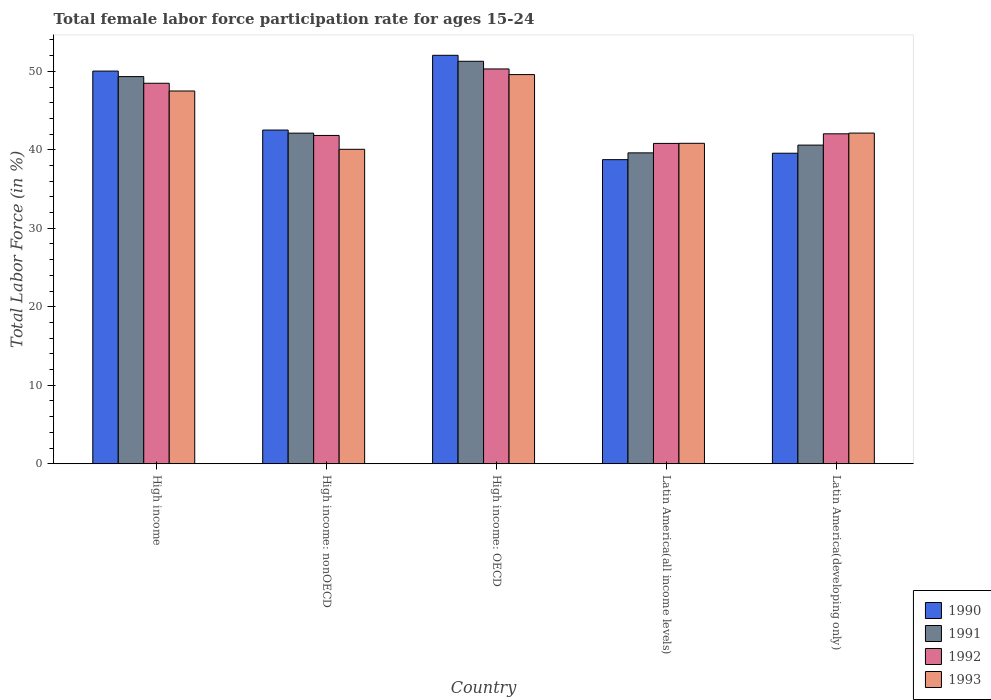Are the number of bars per tick equal to the number of legend labels?
Offer a terse response. Yes. What is the female labor force participation rate in 1993 in High income: nonOECD?
Offer a very short reply. 40.07. Across all countries, what is the maximum female labor force participation rate in 1992?
Your answer should be very brief. 50.3. Across all countries, what is the minimum female labor force participation rate in 1992?
Provide a short and direct response. 40.82. In which country was the female labor force participation rate in 1991 maximum?
Make the answer very short. High income: OECD. In which country was the female labor force participation rate in 1991 minimum?
Your answer should be compact. Latin America(all income levels). What is the total female labor force participation rate in 1990 in the graph?
Your answer should be compact. 222.91. What is the difference between the female labor force participation rate in 1990 in High income: nonOECD and that in Latin America(all income levels)?
Provide a succinct answer. 3.77. What is the difference between the female labor force participation rate in 1993 in High income: nonOECD and the female labor force participation rate in 1992 in Latin America(developing only)?
Provide a succinct answer. -1.97. What is the average female labor force participation rate in 1991 per country?
Provide a succinct answer. 44.59. What is the difference between the female labor force participation rate of/in 1993 and female labor force participation rate of/in 1992 in High income?
Provide a succinct answer. -0.99. In how many countries, is the female labor force participation rate in 1993 greater than 8 %?
Provide a succinct answer. 5. What is the ratio of the female labor force participation rate in 1993 in High income to that in High income: OECD?
Your response must be concise. 0.96. Is the difference between the female labor force participation rate in 1993 in Latin America(all income levels) and Latin America(developing only) greater than the difference between the female labor force participation rate in 1992 in Latin America(all income levels) and Latin America(developing only)?
Provide a short and direct response. No. What is the difference between the highest and the second highest female labor force participation rate in 1992?
Your response must be concise. -1.82. What is the difference between the highest and the lowest female labor force participation rate in 1992?
Your response must be concise. 9.49. Is it the case that in every country, the sum of the female labor force participation rate in 1991 and female labor force participation rate in 1993 is greater than the sum of female labor force participation rate in 1992 and female labor force participation rate in 1990?
Your response must be concise. No. What does the 2nd bar from the right in High income: OECD represents?
Your answer should be compact. 1992. How many countries are there in the graph?
Your answer should be very brief. 5. Does the graph contain any zero values?
Your response must be concise. No. How are the legend labels stacked?
Provide a short and direct response. Vertical. What is the title of the graph?
Make the answer very short. Total female labor force participation rate for ages 15-24. What is the Total Labor Force (in %) in 1990 in High income?
Offer a very short reply. 50.03. What is the Total Labor Force (in %) in 1991 in High income?
Your answer should be very brief. 49.33. What is the Total Labor Force (in %) in 1992 in High income?
Offer a very short reply. 48.48. What is the Total Labor Force (in %) of 1993 in High income?
Offer a very short reply. 47.5. What is the Total Labor Force (in %) in 1990 in High income: nonOECD?
Provide a short and direct response. 42.52. What is the Total Labor Force (in %) in 1991 in High income: nonOECD?
Your response must be concise. 42.12. What is the Total Labor Force (in %) of 1992 in High income: nonOECD?
Provide a succinct answer. 41.83. What is the Total Labor Force (in %) of 1993 in High income: nonOECD?
Offer a terse response. 40.07. What is the Total Labor Force (in %) of 1990 in High income: OECD?
Offer a terse response. 52.04. What is the Total Labor Force (in %) in 1991 in High income: OECD?
Your answer should be compact. 51.28. What is the Total Labor Force (in %) in 1992 in High income: OECD?
Provide a short and direct response. 50.3. What is the Total Labor Force (in %) of 1993 in High income: OECD?
Your answer should be compact. 49.59. What is the Total Labor Force (in %) of 1990 in Latin America(all income levels)?
Ensure brevity in your answer.  38.75. What is the Total Labor Force (in %) of 1991 in Latin America(all income levels)?
Offer a terse response. 39.61. What is the Total Labor Force (in %) in 1992 in Latin America(all income levels)?
Your response must be concise. 40.82. What is the Total Labor Force (in %) of 1993 in Latin America(all income levels)?
Ensure brevity in your answer.  40.83. What is the Total Labor Force (in %) of 1990 in Latin America(developing only)?
Make the answer very short. 39.57. What is the Total Labor Force (in %) in 1991 in Latin America(developing only)?
Ensure brevity in your answer.  40.6. What is the Total Labor Force (in %) of 1992 in Latin America(developing only)?
Give a very brief answer. 42.04. What is the Total Labor Force (in %) of 1993 in Latin America(developing only)?
Offer a terse response. 42.13. Across all countries, what is the maximum Total Labor Force (in %) in 1990?
Offer a very short reply. 52.04. Across all countries, what is the maximum Total Labor Force (in %) in 1991?
Provide a succinct answer. 51.28. Across all countries, what is the maximum Total Labor Force (in %) in 1992?
Provide a succinct answer. 50.3. Across all countries, what is the maximum Total Labor Force (in %) of 1993?
Keep it short and to the point. 49.59. Across all countries, what is the minimum Total Labor Force (in %) in 1990?
Your answer should be compact. 38.75. Across all countries, what is the minimum Total Labor Force (in %) of 1991?
Your response must be concise. 39.61. Across all countries, what is the minimum Total Labor Force (in %) of 1992?
Your answer should be very brief. 40.82. Across all countries, what is the minimum Total Labor Force (in %) of 1993?
Make the answer very short. 40.07. What is the total Total Labor Force (in %) in 1990 in the graph?
Offer a terse response. 222.91. What is the total Total Labor Force (in %) in 1991 in the graph?
Provide a short and direct response. 222.95. What is the total Total Labor Force (in %) in 1992 in the graph?
Ensure brevity in your answer.  223.47. What is the total Total Labor Force (in %) of 1993 in the graph?
Your answer should be very brief. 220.11. What is the difference between the Total Labor Force (in %) of 1990 in High income and that in High income: nonOECD?
Offer a very short reply. 7.52. What is the difference between the Total Labor Force (in %) in 1991 in High income and that in High income: nonOECD?
Offer a terse response. 7.2. What is the difference between the Total Labor Force (in %) in 1992 in High income and that in High income: nonOECD?
Give a very brief answer. 6.65. What is the difference between the Total Labor Force (in %) in 1993 in High income and that in High income: nonOECD?
Provide a succinct answer. 7.43. What is the difference between the Total Labor Force (in %) of 1990 in High income and that in High income: OECD?
Offer a very short reply. -2.01. What is the difference between the Total Labor Force (in %) of 1991 in High income and that in High income: OECD?
Give a very brief answer. -1.95. What is the difference between the Total Labor Force (in %) of 1992 in High income and that in High income: OECD?
Ensure brevity in your answer.  -1.82. What is the difference between the Total Labor Force (in %) of 1993 in High income and that in High income: OECD?
Offer a terse response. -2.09. What is the difference between the Total Labor Force (in %) in 1990 in High income and that in Latin America(all income levels)?
Your response must be concise. 11.29. What is the difference between the Total Labor Force (in %) in 1991 in High income and that in Latin America(all income levels)?
Offer a terse response. 9.72. What is the difference between the Total Labor Force (in %) of 1992 in High income and that in Latin America(all income levels)?
Ensure brevity in your answer.  7.67. What is the difference between the Total Labor Force (in %) in 1993 in High income and that in Latin America(all income levels)?
Ensure brevity in your answer.  6.66. What is the difference between the Total Labor Force (in %) of 1990 in High income and that in Latin America(developing only)?
Your response must be concise. 10.47. What is the difference between the Total Labor Force (in %) in 1991 in High income and that in Latin America(developing only)?
Keep it short and to the point. 8.73. What is the difference between the Total Labor Force (in %) in 1992 in High income and that in Latin America(developing only)?
Keep it short and to the point. 6.44. What is the difference between the Total Labor Force (in %) of 1993 in High income and that in Latin America(developing only)?
Give a very brief answer. 5.36. What is the difference between the Total Labor Force (in %) in 1990 in High income: nonOECD and that in High income: OECD?
Provide a succinct answer. -9.53. What is the difference between the Total Labor Force (in %) of 1991 in High income: nonOECD and that in High income: OECD?
Provide a short and direct response. -9.16. What is the difference between the Total Labor Force (in %) of 1992 in High income: nonOECD and that in High income: OECD?
Ensure brevity in your answer.  -8.47. What is the difference between the Total Labor Force (in %) in 1993 in High income: nonOECD and that in High income: OECD?
Your response must be concise. -9.52. What is the difference between the Total Labor Force (in %) in 1990 in High income: nonOECD and that in Latin America(all income levels)?
Keep it short and to the point. 3.77. What is the difference between the Total Labor Force (in %) in 1991 in High income: nonOECD and that in Latin America(all income levels)?
Offer a terse response. 2.51. What is the difference between the Total Labor Force (in %) of 1992 in High income: nonOECD and that in Latin America(all income levels)?
Offer a terse response. 1.02. What is the difference between the Total Labor Force (in %) of 1993 in High income: nonOECD and that in Latin America(all income levels)?
Offer a very short reply. -0.76. What is the difference between the Total Labor Force (in %) in 1990 in High income: nonOECD and that in Latin America(developing only)?
Keep it short and to the point. 2.95. What is the difference between the Total Labor Force (in %) of 1991 in High income: nonOECD and that in Latin America(developing only)?
Provide a succinct answer. 1.52. What is the difference between the Total Labor Force (in %) in 1992 in High income: nonOECD and that in Latin America(developing only)?
Give a very brief answer. -0.21. What is the difference between the Total Labor Force (in %) of 1993 in High income: nonOECD and that in Latin America(developing only)?
Offer a terse response. -2.07. What is the difference between the Total Labor Force (in %) of 1990 in High income: OECD and that in Latin America(all income levels)?
Your response must be concise. 13.3. What is the difference between the Total Labor Force (in %) in 1991 in High income: OECD and that in Latin America(all income levels)?
Offer a very short reply. 11.67. What is the difference between the Total Labor Force (in %) of 1992 in High income: OECD and that in Latin America(all income levels)?
Your answer should be very brief. 9.49. What is the difference between the Total Labor Force (in %) of 1993 in High income: OECD and that in Latin America(all income levels)?
Ensure brevity in your answer.  8.76. What is the difference between the Total Labor Force (in %) in 1990 in High income: OECD and that in Latin America(developing only)?
Ensure brevity in your answer.  12.48. What is the difference between the Total Labor Force (in %) of 1991 in High income: OECD and that in Latin America(developing only)?
Your response must be concise. 10.68. What is the difference between the Total Labor Force (in %) in 1992 in High income: OECD and that in Latin America(developing only)?
Provide a short and direct response. 8.26. What is the difference between the Total Labor Force (in %) in 1993 in High income: OECD and that in Latin America(developing only)?
Offer a very short reply. 7.45. What is the difference between the Total Labor Force (in %) of 1990 in Latin America(all income levels) and that in Latin America(developing only)?
Provide a succinct answer. -0.82. What is the difference between the Total Labor Force (in %) in 1991 in Latin America(all income levels) and that in Latin America(developing only)?
Your response must be concise. -0.99. What is the difference between the Total Labor Force (in %) in 1992 in Latin America(all income levels) and that in Latin America(developing only)?
Offer a terse response. -1.23. What is the difference between the Total Labor Force (in %) in 1993 in Latin America(all income levels) and that in Latin America(developing only)?
Your response must be concise. -1.3. What is the difference between the Total Labor Force (in %) of 1990 in High income and the Total Labor Force (in %) of 1991 in High income: nonOECD?
Your answer should be compact. 7.91. What is the difference between the Total Labor Force (in %) of 1990 in High income and the Total Labor Force (in %) of 1992 in High income: nonOECD?
Ensure brevity in your answer.  8.2. What is the difference between the Total Labor Force (in %) in 1990 in High income and the Total Labor Force (in %) in 1993 in High income: nonOECD?
Give a very brief answer. 9.97. What is the difference between the Total Labor Force (in %) in 1991 in High income and the Total Labor Force (in %) in 1992 in High income: nonOECD?
Keep it short and to the point. 7.5. What is the difference between the Total Labor Force (in %) in 1991 in High income and the Total Labor Force (in %) in 1993 in High income: nonOECD?
Keep it short and to the point. 9.26. What is the difference between the Total Labor Force (in %) in 1992 in High income and the Total Labor Force (in %) in 1993 in High income: nonOECD?
Offer a terse response. 8.42. What is the difference between the Total Labor Force (in %) of 1990 in High income and the Total Labor Force (in %) of 1991 in High income: OECD?
Your answer should be very brief. -1.25. What is the difference between the Total Labor Force (in %) of 1990 in High income and the Total Labor Force (in %) of 1992 in High income: OECD?
Give a very brief answer. -0.27. What is the difference between the Total Labor Force (in %) in 1990 in High income and the Total Labor Force (in %) in 1993 in High income: OECD?
Offer a very short reply. 0.45. What is the difference between the Total Labor Force (in %) in 1991 in High income and the Total Labor Force (in %) in 1992 in High income: OECD?
Your response must be concise. -0.98. What is the difference between the Total Labor Force (in %) in 1991 in High income and the Total Labor Force (in %) in 1993 in High income: OECD?
Provide a succinct answer. -0.26. What is the difference between the Total Labor Force (in %) of 1992 in High income and the Total Labor Force (in %) of 1993 in High income: OECD?
Your answer should be compact. -1.1. What is the difference between the Total Labor Force (in %) of 1990 in High income and the Total Labor Force (in %) of 1991 in Latin America(all income levels)?
Keep it short and to the point. 10.42. What is the difference between the Total Labor Force (in %) of 1990 in High income and the Total Labor Force (in %) of 1992 in Latin America(all income levels)?
Offer a terse response. 9.22. What is the difference between the Total Labor Force (in %) in 1990 in High income and the Total Labor Force (in %) in 1993 in Latin America(all income levels)?
Offer a terse response. 9.2. What is the difference between the Total Labor Force (in %) in 1991 in High income and the Total Labor Force (in %) in 1992 in Latin America(all income levels)?
Offer a terse response. 8.51. What is the difference between the Total Labor Force (in %) of 1991 in High income and the Total Labor Force (in %) of 1993 in Latin America(all income levels)?
Your response must be concise. 8.5. What is the difference between the Total Labor Force (in %) in 1992 in High income and the Total Labor Force (in %) in 1993 in Latin America(all income levels)?
Your response must be concise. 7.65. What is the difference between the Total Labor Force (in %) in 1990 in High income and the Total Labor Force (in %) in 1991 in Latin America(developing only)?
Make the answer very short. 9.43. What is the difference between the Total Labor Force (in %) of 1990 in High income and the Total Labor Force (in %) of 1992 in Latin America(developing only)?
Your answer should be compact. 7.99. What is the difference between the Total Labor Force (in %) in 1990 in High income and the Total Labor Force (in %) in 1993 in Latin America(developing only)?
Make the answer very short. 7.9. What is the difference between the Total Labor Force (in %) of 1991 in High income and the Total Labor Force (in %) of 1992 in Latin America(developing only)?
Offer a very short reply. 7.29. What is the difference between the Total Labor Force (in %) of 1991 in High income and the Total Labor Force (in %) of 1993 in Latin America(developing only)?
Offer a terse response. 7.2. What is the difference between the Total Labor Force (in %) in 1992 in High income and the Total Labor Force (in %) in 1993 in Latin America(developing only)?
Your answer should be very brief. 6.35. What is the difference between the Total Labor Force (in %) of 1990 in High income: nonOECD and the Total Labor Force (in %) of 1991 in High income: OECD?
Provide a short and direct response. -8.76. What is the difference between the Total Labor Force (in %) in 1990 in High income: nonOECD and the Total Labor Force (in %) in 1992 in High income: OECD?
Your answer should be very brief. -7.79. What is the difference between the Total Labor Force (in %) in 1990 in High income: nonOECD and the Total Labor Force (in %) in 1993 in High income: OECD?
Ensure brevity in your answer.  -7.07. What is the difference between the Total Labor Force (in %) of 1991 in High income: nonOECD and the Total Labor Force (in %) of 1992 in High income: OECD?
Offer a very short reply. -8.18. What is the difference between the Total Labor Force (in %) in 1991 in High income: nonOECD and the Total Labor Force (in %) in 1993 in High income: OECD?
Ensure brevity in your answer.  -7.46. What is the difference between the Total Labor Force (in %) in 1992 in High income: nonOECD and the Total Labor Force (in %) in 1993 in High income: OECD?
Your response must be concise. -7.75. What is the difference between the Total Labor Force (in %) of 1990 in High income: nonOECD and the Total Labor Force (in %) of 1991 in Latin America(all income levels)?
Give a very brief answer. 2.91. What is the difference between the Total Labor Force (in %) of 1990 in High income: nonOECD and the Total Labor Force (in %) of 1992 in Latin America(all income levels)?
Ensure brevity in your answer.  1.7. What is the difference between the Total Labor Force (in %) in 1990 in High income: nonOECD and the Total Labor Force (in %) in 1993 in Latin America(all income levels)?
Keep it short and to the point. 1.69. What is the difference between the Total Labor Force (in %) in 1991 in High income: nonOECD and the Total Labor Force (in %) in 1992 in Latin America(all income levels)?
Make the answer very short. 1.31. What is the difference between the Total Labor Force (in %) in 1991 in High income: nonOECD and the Total Labor Force (in %) in 1993 in Latin America(all income levels)?
Offer a very short reply. 1.29. What is the difference between the Total Labor Force (in %) in 1990 in High income: nonOECD and the Total Labor Force (in %) in 1991 in Latin America(developing only)?
Your answer should be very brief. 1.92. What is the difference between the Total Labor Force (in %) of 1990 in High income: nonOECD and the Total Labor Force (in %) of 1992 in Latin America(developing only)?
Make the answer very short. 0.48. What is the difference between the Total Labor Force (in %) of 1990 in High income: nonOECD and the Total Labor Force (in %) of 1993 in Latin America(developing only)?
Give a very brief answer. 0.39. What is the difference between the Total Labor Force (in %) of 1991 in High income: nonOECD and the Total Labor Force (in %) of 1992 in Latin America(developing only)?
Give a very brief answer. 0.08. What is the difference between the Total Labor Force (in %) of 1991 in High income: nonOECD and the Total Labor Force (in %) of 1993 in Latin America(developing only)?
Your answer should be compact. -0.01. What is the difference between the Total Labor Force (in %) in 1992 in High income: nonOECD and the Total Labor Force (in %) in 1993 in Latin America(developing only)?
Your answer should be compact. -0.3. What is the difference between the Total Labor Force (in %) of 1990 in High income: OECD and the Total Labor Force (in %) of 1991 in Latin America(all income levels)?
Provide a short and direct response. 12.43. What is the difference between the Total Labor Force (in %) in 1990 in High income: OECD and the Total Labor Force (in %) in 1992 in Latin America(all income levels)?
Give a very brief answer. 11.23. What is the difference between the Total Labor Force (in %) of 1990 in High income: OECD and the Total Labor Force (in %) of 1993 in Latin America(all income levels)?
Offer a very short reply. 11.21. What is the difference between the Total Labor Force (in %) in 1991 in High income: OECD and the Total Labor Force (in %) in 1992 in Latin America(all income levels)?
Provide a short and direct response. 10.47. What is the difference between the Total Labor Force (in %) in 1991 in High income: OECD and the Total Labor Force (in %) in 1993 in Latin America(all income levels)?
Give a very brief answer. 10.45. What is the difference between the Total Labor Force (in %) of 1992 in High income: OECD and the Total Labor Force (in %) of 1993 in Latin America(all income levels)?
Your answer should be compact. 9.47. What is the difference between the Total Labor Force (in %) of 1990 in High income: OECD and the Total Labor Force (in %) of 1991 in Latin America(developing only)?
Your answer should be very brief. 11.44. What is the difference between the Total Labor Force (in %) of 1990 in High income: OECD and the Total Labor Force (in %) of 1992 in Latin America(developing only)?
Keep it short and to the point. 10. What is the difference between the Total Labor Force (in %) of 1990 in High income: OECD and the Total Labor Force (in %) of 1993 in Latin America(developing only)?
Offer a very short reply. 9.91. What is the difference between the Total Labor Force (in %) in 1991 in High income: OECD and the Total Labor Force (in %) in 1992 in Latin America(developing only)?
Your response must be concise. 9.24. What is the difference between the Total Labor Force (in %) in 1991 in High income: OECD and the Total Labor Force (in %) in 1993 in Latin America(developing only)?
Provide a short and direct response. 9.15. What is the difference between the Total Labor Force (in %) of 1992 in High income: OECD and the Total Labor Force (in %) of 1993 in Latin America(developing only)?
Give a very brief answer. 8.17. What is the difference between the Total Labor Force (in %) of 1990 in Latin America(all income levels) and the Total Labor Force (in %) of 1991 in Latin America(developing only)?
Offer a terse response. -1.85. What is the difference between the Total Labor Force (in %) in 1990 in Latin America(all income levels) and the Total Labor Force (in %) in 1992 in Latin America(developing only)?
Offer a terse response. -3.29. What is the difference between the Total Labor Force (in %) of 1990 in Latin America(all income levels) and the Total Labor Force (in %) of 1993 in Latin America(developing only)?
Give a very brief answer. -3.38. What is the difference between the Total Labor Force (in %) of 1991 in Latin America(all income levels) and the Total Labor Force (in %) of 1992 in Latin America(developing only)?
Your answer should be compact. -2.43. What is the difference between the Total Labor Force (in %) of 1991 in Latin America(all income levels) and the Total Labor Force (in %) of 1993 in Latin America(developing only)?
Give a very brief answer. -2.52. What is the difference between the Total Labor Force (in %) of 1992 in Latin America(all income levels) and the Total Labor Force (in %) of 1993 in Latin America(developing only)?
Your answer should be very brief. -1.32. What is the average Total Labor Force (in %) of 1990 per country?
Offer a terse response. 44.58. What is the average Total Labor Force (in %) of 1991 per country?
Offer a very short reply. 44.59. What is the average Total Labor Force (in %) of 1992 per country?
Provide a short and direct response. 44.69. What is the average Total Labor Force (in %) of 1993 per country?
Your answer should be very brief. 44.02. What is the difference between the Total Labor Force (in %) in 1990 and Total Labor Force (in %) in 1991 in High income?
Keep it short and to the point. 0.71. What is the difference between the Total Labor Force (in %) in 1990 and Total Labor Force (in %) in 1992 in High income?
Your answer should be very brief. 1.55. What is the difference between the Total Labor Force (in %) in 1990 and Total Labor Force (in %) in 1993 in High income?
Make the answer very short. 2.54. What is the difference between the Total Labor Force (in %) of 1991 and Total Labor Force (in %) of 1992 in High income?
Your response must be concise. 0.85. What is the difference between the Total Labor Force (in %) in 1991 and Total Labor Force (in %) in 1993 in High income?
Keep it short and to the point. 1.83. What is the difference between the Total Labor Force (in %) in 1992 and Total Labor Force (in %) in 1993 in High income?
Provide a short and direct response. 0.99. What is the difference between the Total Labor Force (in %) of 1990 and Total Labor Force (in %) of 1991 in High income: nonOECD?
Make the answer very short. 0.39. What is the difference between the Total Labor Force (in %) of 1990 and Total Labor Force (in %) of 1992 in High income: nonOECD?
Ensure brevity in your answer.  0.69. What is the difference between the Total Labor Force (in %) in 1990 and Total Labor Force (in %) in 1993 in High income: nonOECD?
Make the answer very short. 2.45. What is the difference between the Total Labor Force (in %) in 1991 and Total Labor Force (in %) in 1992 in High income: nonOECD?
Provide a succinct answer. 0.29. What is the difference between the Total Labor Force (in %) in 1991 and Total Labor Force (in %) in 1993 in High income: nonOECD?
Ensure brevity in your answer.  2.06. What is the difference between the Total Labor Force (in %) of 1992 and Total Labor Force (in %) of 1993 in High income: nonOECD?
Provide a succinct answer. 1.77. What is the difference between the Total Labor Force (in %) of 1990 and Total Labor Force (in %) of 1991 in High income: OECD?
Ensure brevity in your answer.  0.76. What is the difference between the Total Labor Force (in %) of 1990 and Total Labor Force (in %) of 1992 in High income: OECD?
Give a very brief answer. 1.74. What is the difference between the Total Labor Force (in %) of 1990 and Total Labor Force (in %) of 1993 in High income: OECD?
Provide a short and direct response. 2.46. What is the difference between the Total Labor Force (in %) in 1991 and Total Labor Force (in %) in 1992 in High income: OECD?
Offer a very short reply. 0.98. What is the difference between the Total Labor Force (in %) of 1991 and Total Labor Force (in %) of 1993 in High income: OECD?
Offer a terse response. 1.7. What is the difference between the Total Labor Force (in %) of 1992 and Total Labor Force (in %) of 1993 in High income: OECD?
Make the answer very short. 0.72. What is the difference between the Total Labor Force (in %) in 1990 and Total Labor Force (in %) in 1991 in Latin America(all income levels)?
Your answer should be compact. -0.86. What is the difference between the Total Labor Force (in %) of 1990 and Total Labor Force (in %) of 1992 in Latin America(all income levels)?
Ensure brevity in your answer.  -2.07. What is the difference between the Total Labor Force (in %) in 1990 and Total Labor Force (in %) in 1993 in Latin America(all income levels)?
Your answer should be very brief. -2.08. What is the difference between the Total Labor Force (in %) in 1991 and Total Labor Force (in %) in 1992 in Latin America(all income levels)?
Your answer should be very brief. -1.2. What is the difference between the Total Labor Force (in %) in 1991 and Total Labor Force (in %) in 1993 in Latin America(all income levels)?
Your answer should be very brief. -1.22. What is the difference between the Total Labor Force (in %) in 1992 and Total Labor Force (in %) in 1993 in Latin America(all income levels)?
Make the answer very short. -0.02. What is the difference between the Total Labor Force (in %) of 1990 and Total Labor Force (in %) of 1991 in Latin America(developing only)?
Your answer should be very brief. -1.04. What is the difference between the Total Labor Force (in %) of 1990 and Total Labor Force (in %) of 1992 in Latin America(developing only)?
Provide a succinct answer. -2.48. What is the difference between the Total Labor Force (in %) in 1990 and Total Labor Force (in %) in 1993 in Latin America(developing only)?
Offer a very short reply. -2.57. What is the difference between the Total Labor Force (in %) in 1991 and Total Labor Force (in %) in 1992 in Latin America(developing only)?
Provide a short and direct response. -1.44. What is the difference between the Total Labor Force (in %) in 1991 and Total Labor Force (in %) in 1993 in Latin America(developing only)?
Make the answer very short. -1.53. What is the difference between the Total Labor Force (in %) in 1992 and Total Labor Force (in %) in 1993 in Latin America(developing only)?
Ensure brevity in your answer.  -0.09. What is the ratio of the Total Labor Force (in %) in 1990 in High income to that in High income: nonOECD?
Offer a terse response. 1.18. What is the ratio of the Total Labor Force (in %) of 1991 in High income to that in High income: nonOECD?
Offer a terse response. 1.17. What is the ratio of the Total Labor Force (in %) in 1992 in High income to that in High income: nonOECD?
Ensure brevity in your answer.  1.16. What is the ratio of the Total Labor Force (in %) of 1993 in High income to that in High income: nonOECD?
Make the answer very short. 1.19. What is the ratio of the Total Labor Force (in %) of 1990 in High income to that in High income: OECD?
Provide a short and direct response. 0.96. What is the ratio of the Total Labor Force (in %) in 1991 in High income to that in High income: OECD?
Offer a very short reply. 0.96. What is the ratio of the Total Labor Force (in %) in 1992 in High income to that in High income: OECD?
Make the answer very short. 0.96. What is the ratio of the Total Labor Force (in %) in 1993 in High income to that in High income: OECD?
Keep it short and to the point. 0.96. What is the ratio of the Total Labor Force (in %) of 1990 in High income to that in Latin America(all income levels)?
Provide a succinct answer. 1.29. What is the ratio of the Total Labor Force (in %) of 1991 in High income to that in Latin America(all income levels)?
Your answer should be very brief. 1.25. What is the ratio of the Total Labor Force (in %) in 1992 in High income to that in Latin America(all income levels)?
Provide a short and direct response. 1.19. What is the ratio of the Total Labor Force (in %) of 1993 in High income to that in Latin America(all income levels)?
Provide a short and direct response. 1.16. What is the ratio of the Total Labor Force (in %) in 1990 in High income to that in Latin America(developing only)?
Offer a terse response. 1.26. What is the ratio of the Total Labor Force (in %) of 1991 in High income to that in Latin America(developing only)?
Your answer should be very brief. 1.22. What is the ratio of the Total Labor Force (in %) of 1992 in High income to that in Latin America(developing only)?
Provide a succinct answer. 1.15. What is the ratio of the Total Labor Force (in %) of 1993 in High income to that in Latin America(developing only)?
Provide a short and direct response. 1.13. What is the ratio of the Total Labor Force (in %) of 1990 in High income: nonOECD to that in High income: OECD?
Give a very brief answer. 0.82. What is the ratio of the Total Labor Force (in %) in 1991 in High income: nonOECD to that in High income: OECD?
Provide a succinct answer. 0.82. What is the ratio of the Total Labor Force (in %) of 1992 in High income: nonOECD to that in High income: OECD?
Provide a succinct answer. 0.83. What is the ratio of the Total Labor Force (in %) in 1993 in High income: nonOECD to that in High income: OECD?
Give a very brief answer. 0.81. What is the ratio of the Total Labor Force (in %) in 1990 in High income: nonOECD to that in Latin America(all income levels)?
Give a very brief answer. 1.1. What is the ratio of the Total Labor Force (in %) in 1991 in High income: nonOECD to that in Latin America(all income levels)?
Offer a very short reply. 1.06. What is the ratio of the Total Labor Force (in %) in 1992 in High income: nonOECD to that in Latin America(all income levels)?
Your response must be concise. 1.02. What is the ratio of the Total Labor Force (in %) in 1993 in High income: nonOECD to that in Latin America(all income levels)?
Offer a very short reply. 0.98. What is the ratio of the Total Labor Force (in %) of 1990 in High income: nonOECD to that in Latin America(developing only)?
Offer a very short reply. 1.07. What is the ratio of the Total Labor Force (in %) of 1991 in High income: nonOECD to that in Latin America(developing only)?
Offer a very short reply. 1.04. What is the ratio of the Total Labor Force (in %) of 1992 in High income: nonOECD to that in Latin America(developing only)?
Give a very brief answer. 0.99. What is the ratio of the Total Labor Force (in %) in 1993 in High income: nonOECD to that in Latin America(developing only)?
Provide a succinct answer. 0.95. What is the ratio of the Total Labor Force (in %) in 1990 in High income: OECD to that in Latin America(all income levels)?
Make the answer very short. 1.34. What is the ratio of the Total Labor Force (in %) in 1991 in High income: OECD to that in Latin America(all income levels)?
Make the answer very short. 1.29. What is the ratio of the Total Labor Force (in %) in 1992 in High income: OECD to that in Latin America(all income levels)?
Offer a terse response. 1.23. What is the ratio of the Total Labor Force (in %) in 1993 in High income: OECD to that in Latin America(all income levels)?
Make the answer very short. 1.21. What is the ratio of the Total Labor Force (in %) of 1990 in High income: OECD to that in Latin America(developing only)?
Offer a very short reply. 1.32. What is the ratio of the Total Labor Force (in %) in 1991 in High income: OECD to that in Latin America(developing only)?
Give a very brief answer. 1.26. What is the ratio of the Total Labor Force (in %) of 1992 in High income: OECD to that in Latin America(developing only)?
Provide a succinct answer. 1.2. What is the ratio of the Total Labor Force (in %) in 1993 in High income: OECD to that in Latin America(developing only)?
Offer a terse response. 1.18. What is the ratio of the Total Labor Force (in %) of 1990 in Latin America(all income levels) to that in Latin America(developing only)?
Provide a short and direct response. 0.98. What is the ratio of the Total Labor Force (in %) in 1991 in Latin America(all income levels) to that in Latin America(developing only)?
Ensure brevity in your answer.  0.98. What is the ratio of the Total Labor Force (in %) of 1992 in Latin America(all income levels) to that in Latin America(developing only)?
Offer a very short reply. 0.97. What is the ratio of the Total Labor Force (in %) of 1993 in Latin America(all income levels) to that in Latin America(developing only)?
Your answer should be very brief. 0.97. What is the difference between the highest and the second highest Total Labor Force (in %) of 1990?
Your response must be concise. 2.01. What is the difference between the highest and the second highest Total Labor Force (in %) in 1991?
Offer a very short reply. 1.95. What is the difference between the highest and the second highest Total Labor Force (in %) of 1992?
Ensure brevity in your answer.  1.82. What is the difference between the highest and the second highest Total Labor Force (in %) in 1993?
Your response must be concise. 2.09. What is the difference between the highest and the lowest Total Labor Force (in %) in 1990?
Offer a terse response. 13.3. What is the difference between the highest and the lowest Total Labor Force (in %) of 1991?
Provide a short and direct response. 11.67. What is the difference between the highest and the lowest Total Labor Force (in %) in 1992?
Offer a very short reply. 9.49. What is the difference between the highest and the lowest Total Labor Force (in %) in 1993?
Give a very brief answer. 9.52. 